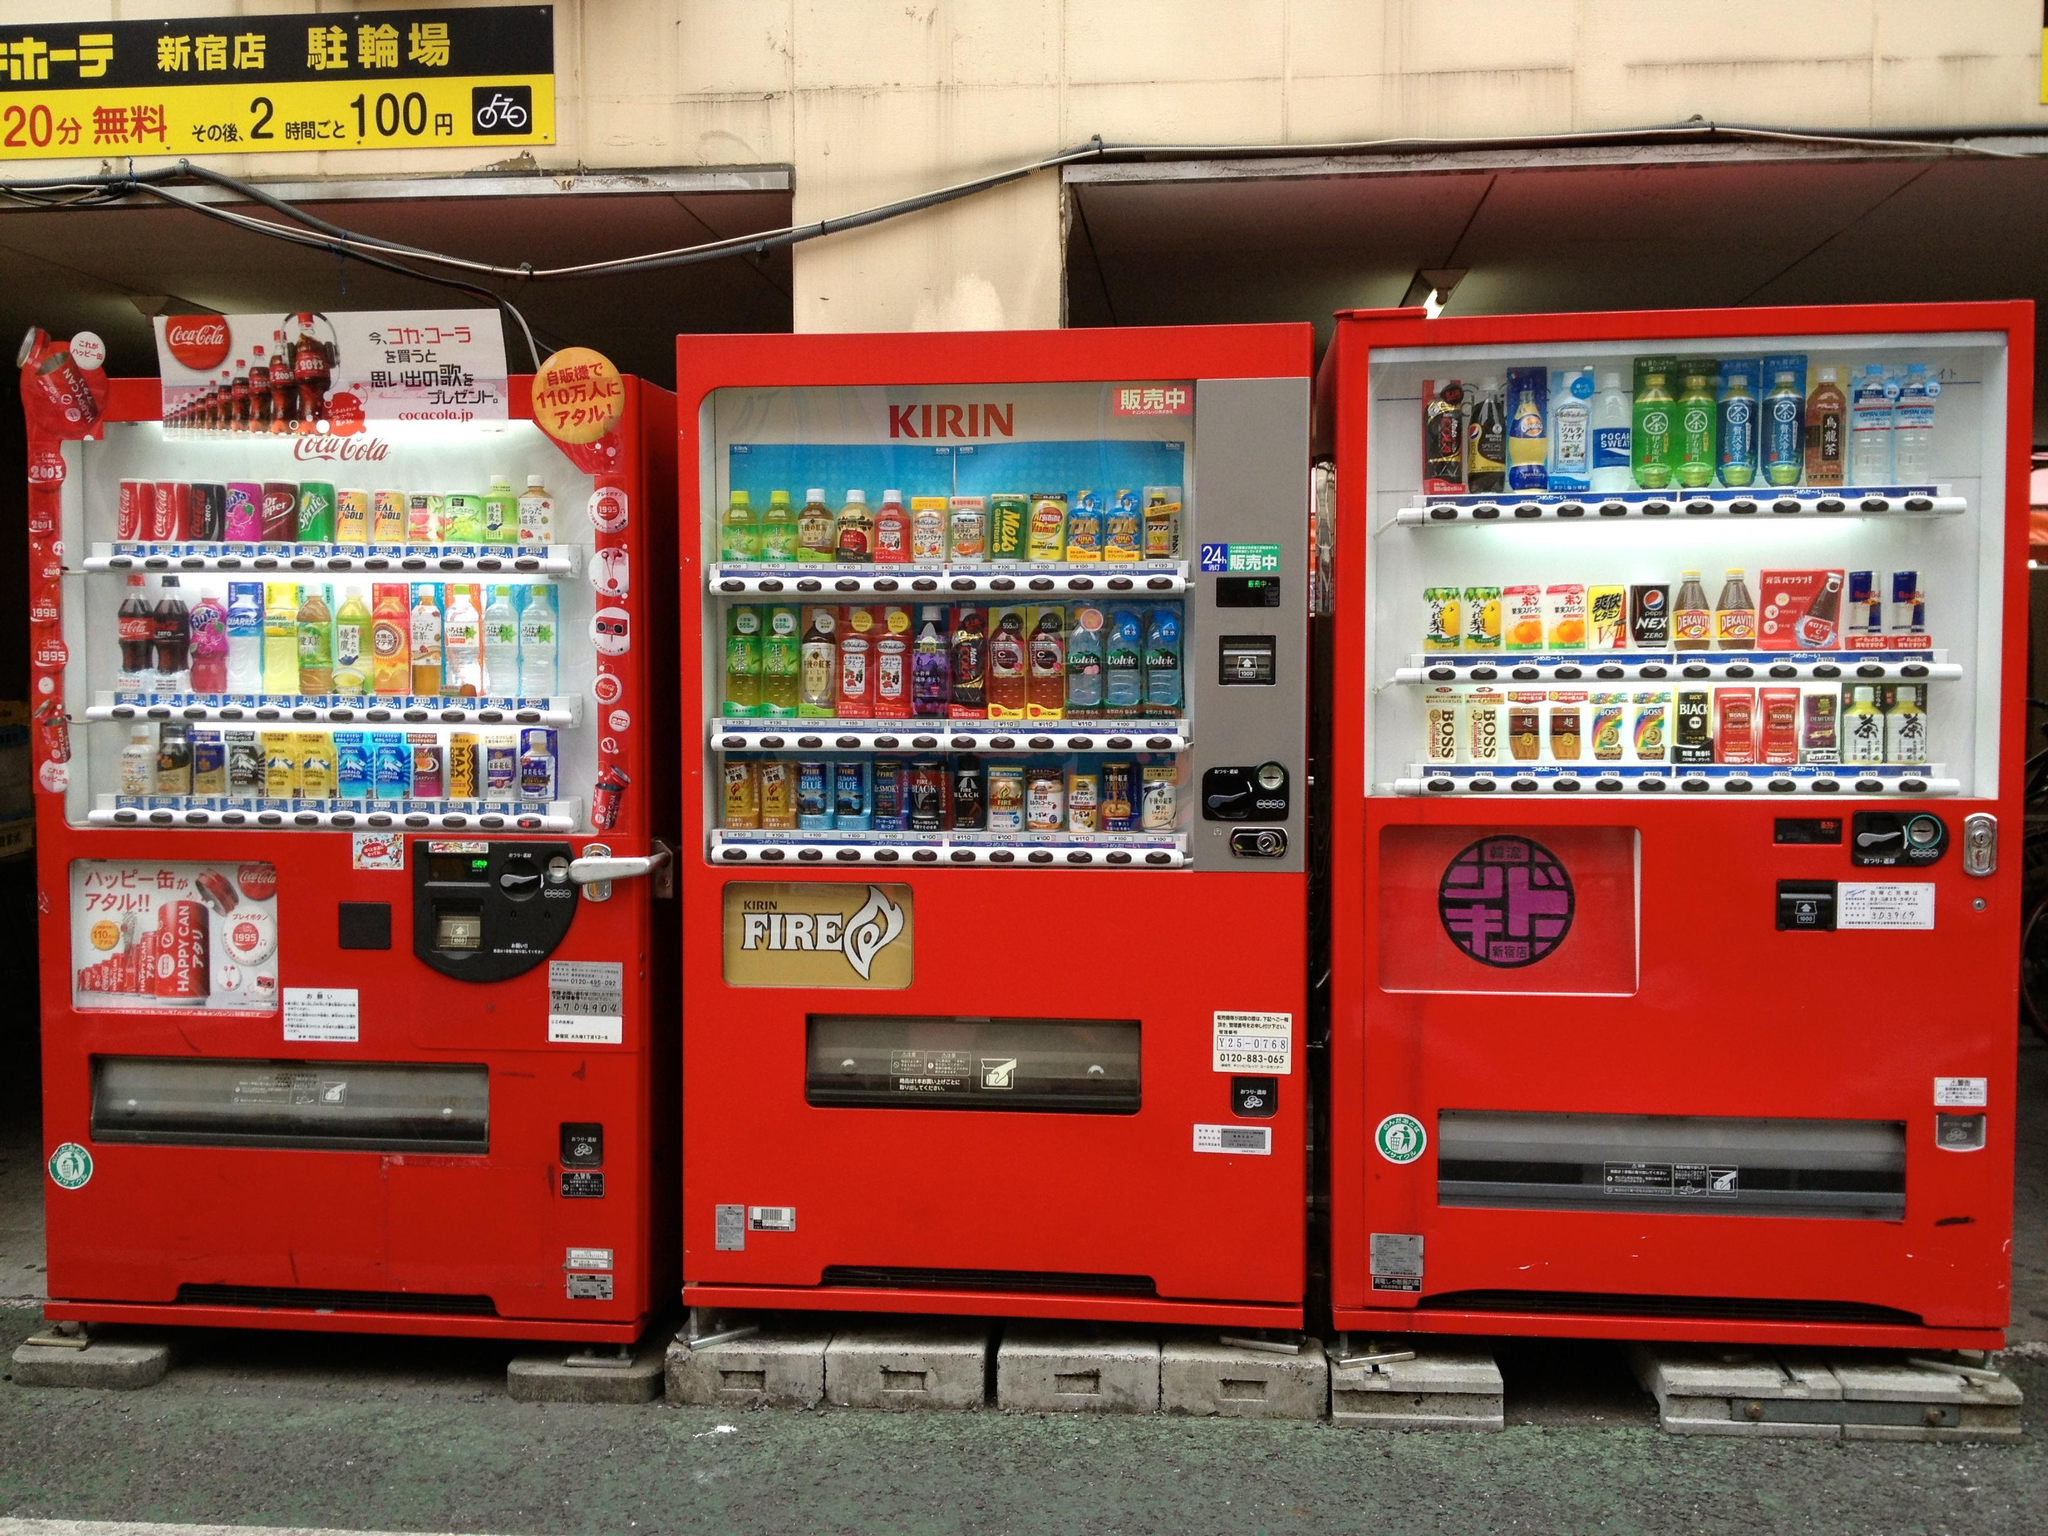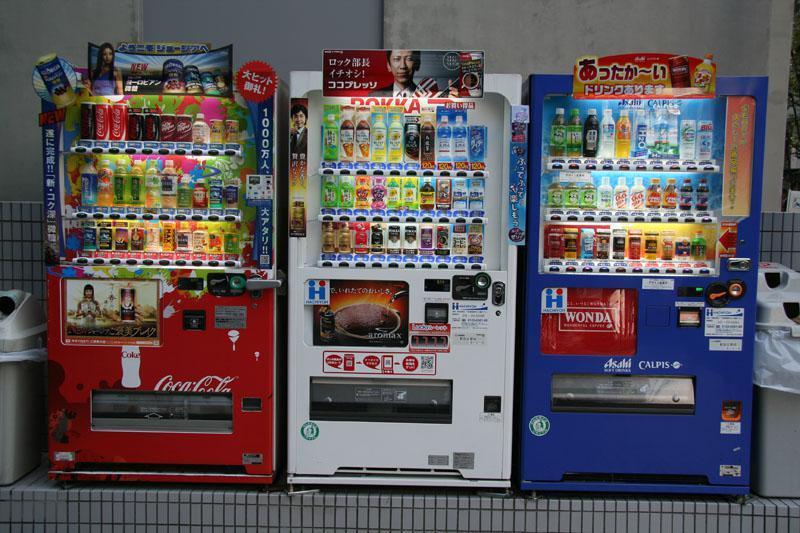The first image is the image on the left, the second image is the image on the right. Assess this claim about the two images: "One of the machines sitting amongst the others is blue.". Correct or not? Answer yes or no. Yes. The first image is the image on the left, the second image is the image on the right. Examine the images to the left and right. Is the description "Each image shows a row of at least three vending machines." accurate? Answer yes or no. Yes. The first image is the image on the left, the second image is the image on the right. Evaluate the accuracy of this statement regarding the images: "There are no more than three vending machines in the image on the right.". Is it true? Answer yes or no. Yes. The first image is the image on the left, the second image is the image on the right. Given the left and right images, does the statement "The left image has a food vending machine, the right image has a beverage vending machine." hold true? Answer yes or no. No. The first image is the image on the left, the second image is the image on the right. Examine the images to the left and right. Is the description "One photo shows a white vending machine that clearly offers food rather than beverages." accurate? Answer yes or no. No. 